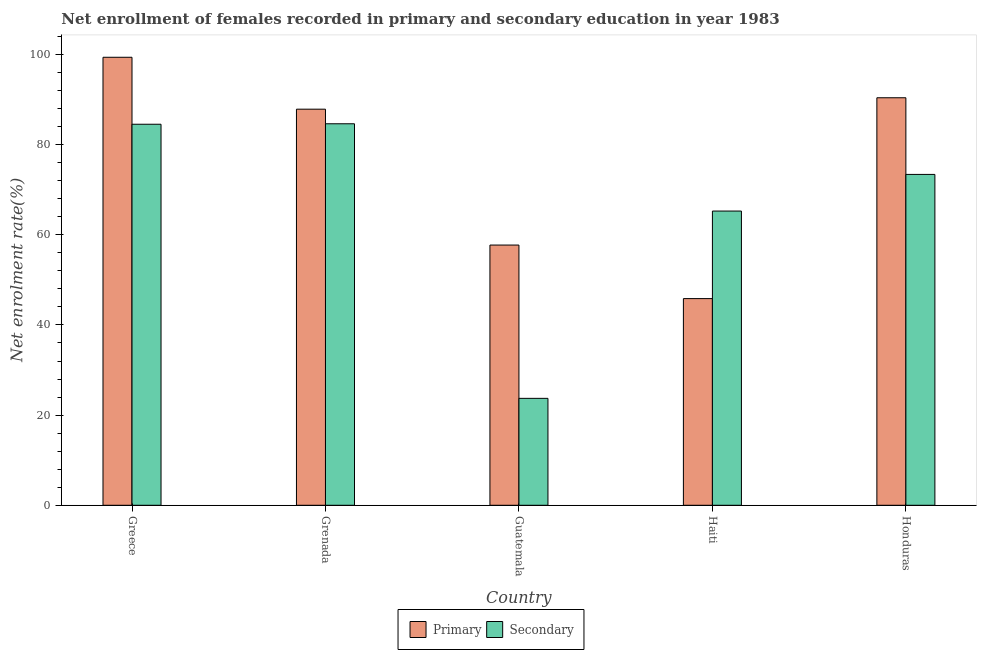How many different coloured bars are there?
Offer a very short reply. 2. Are the number of bars on each tick of the X-axis equal?
Keep it short and to the point. Yes. What is the label of the 3rd group of bars from the left?
Offer a very short reply. Guatemala. In how many cases, is the number of bars for a given country not equal to the number of legend labels?
Provide a short and direct response. 0. What is the enrollment rate in secondary education in Grenada?
Make the answer very short. 84.62. Across all countries, what is the maximum enrollment rate in primary education?
Keep it short and to the point. 99.37. Across all countries, what is the minimum enrollment rate in secondary education?
Keep it short and to the point. 23.71. In which country was the enrollment rate in secondary education maximum?
Your answer should be very brief. Grenada. In which country was the enrollment rate in secondary education minimum?
Your response must be concise. Guatemala. What is the total enrollment rate in primary education in the graph?
Provide a short and direct response. 381.18. What is the difference between the enrollment rate in secondary education in Greece and that in Guatemala?
Ensure brevity in your answer.  60.8. What is the difference between the enrollment rate in secondary education in Grenada and the enrollment rate in primary education in Honduras?
Your answer should be compact. -5.77. What is the average enrollment rate in primary education per country?
Ensure brevity in your answer.  76.24. What is the difference between the enrollment rate in secondary education and enrollment rate in primary education in Guatemala?
Offer a very short reply. -34. In how many countries, is the enrollment rate in secondary education greater than 72 %?
Provide a succinct answer. 3. What is the ratio of the enrollment rate in secondary education in Greece to that in Grenada?
Keep it short and to the point. 1. What is the difference between the highest and the second highest enrollment rate in primary education?
Give a very brief answer. 8.98. What is the difference between the highest and the lowest enrollment rate in secondary education?
Provide a succinct answer. 60.91. What does the 1st bar from the left in Haiti represents?
Offer a very short reply. Primary. What does the 1st bar from the right in Honduras represents?
Provide a succinct answer. Secondary. Are all the bars in the graph horizontal?
Your answer should be compact. No. How many countries are there in the graph?
Offer a very short reply. 5. What is the difference between two consecutive major ticks on the Y-axis?
Your answer should be compact. 20. Does the graph contain any zero values?
Offer a terse response. No. Does the graph contain grids?
Give a very brief answer. No. How many legend labels are there?
Provide a succinct answer. 2. How are the legend labels stacked?
Keep it short and to the point. Horizontal. What is the title of the graph?
Offer a very short reply. Net enrollment of females recorded in primary and secondary education in year 1983. Does "Females" appear as one of the legend labels in the graph?
Your response must be concise. No. What is the label or title of the Y-axis?
Provide a succinct answer. Net enrolment rate(%). What is the Net enrolment rate(%) of Primary in Greece?
Ensure brevity in your answer.  99.37. What is the Net enrolment rate(%) of Secondary in Greece?
Make the answer very short. 84.52. What is the Net enrolment rate(%) in Primary in Grenada?
Ensure brevity in your answer.  87.86. What is the Net enrolment rate(%) of Secondary in Grenada?
Keep it short and to the point. 84.62. What is the Net enrolment rate(%) in Primary in Guatemala?
Give a very brief answer. 57.72. What is the Net enrolment rate(%) in Secondary in Guatemala?
Offer a terse response. 23.71. What is the Net enrolment rate(%) of Primary in Haiti?
Make the answer very short. 45.84. What is the Net enrolment rate(%) in Secondary in Haiti?
Ensure brevity in your answer.  65.26. What is the Net enrolment rate(%) of Primary in Honduras?
Offer a terse response. 90.39. What is the Net enrolment rate(%) in Secondary in Honduras?
Your response must be concise. 73.39. Across all countries, what is the maximum Net enrolment rate(%) in Primary?
Your answer should be very brief. 99.37. Across all countries, what is the maximum Net enrolment rate(%) in Secondary?
Offer a very short reply. 84.62. Across all countries, what is the minimum Net enrolment rate(%) of Primary?
Provide a succinct answer. 45.84. Across all countries, what is the minimum Net enrolment rate(%) in Secondary?
Keep it short and to the point. 23.71. What is the total Net enrolment rate(%) in Primary in the graph?
Your response must be concise. 381.18. What is the total Net enrolment rate(%) in Secondary in the graph?
Your response must be concise. 331.5. What is the difference between the Net enrolment rate(%) in Primary in Greece and that in Grenada?
Provide a succinct answer. 11.51. What is the difference between the Net enrolment rate(%) of Secondary in Greece and that in Grenada?
Offer a terse response. -0.1. What is the difference between the Net enrolment rate(%) in Primary in Greece and that in Guatemala?
Make the answer very short. 41.65. What is the difference between the Net enrolment rate(%) of Secondary in Greece and that in Guatemala?
Make the answer very short. 60.8. What is the difference between the Net enrolment rate(%) in Primary in Greece and that in Haiti?
Your response must be concise. 53.53. What is the difference between the Net enrolment rate(%) of Secondary in Greece and that in Haiti?
Offer a very short reply. 19.25. What is the difference between the Net enrolment rate(%) of Primary in Greece and that in Honduras?
Make the answer very short. 8.98. What is the difference between the Net enrolment rate(%) of Secondary in Greece and that in Honduras?
Your answer should be compact. 11.13. What is the difference between the Net enrolment rate(%) of Primary in Grenada and that in Guatemala?
Provide a short and direct response. 30.14. What is the difference between the Net enrolment rate(%) in Secondary in Grenada and that in Guatemala?
Give a very brief answer. 60.91. What is the difference between the Net enrolment rate(%) of Primary in Grenada and that in Haiti?
Your answer should be compact. 42.02. What is the difference between the Net enrolment rate(%) of Secondary in Grenada and that in Haiti?
Make the answer very short. 19.36. What is the difference between the Net enrolment rate(%) in Primary in Grenada and that in Honduras?
Make the answer very short. -2.53. What is the difference between the Net enrolment rate(%) of Secondary in Grenada and that in Honduras?
Provide a short and direct response. 11.23. What is the difference between the Net enrolment rate(%) in Primary in Guatemala and that in Haiti?
Your answer should be compact. 11.88. What is the difference between the Net enrolment rate(%) of Secondary in Guatemala and that in Haiti?
Provide a short and direct response. -41.55. What is the difference between the Net enrolment rate(%) in Primary in Guatemala and that in Honduras?
Offer a terse response. -32.67. What is the difference between the Net enrolment rate(%) in Secondary in Guatemala and that in Honduras?
Ensure brevity in your answer.  -49.67. What is the difference between the Net enrolment rate(%) of Primary in Haiti and that in Honduras?
Keep it short and to the point. -44.55. What is the difference between the Net enrolment rate(%) in Secondary in Haiti and that in Honduras?
Give a very brief answer. -8.13. What is the difference between the Net enrolment rate(%) of Primary in Greece and the Net enrolment rate(%) of Secondary in Grenada?
Provide a short and direct response. 14.75. What is the difference between the Net enrolment rate(%) of Primary in Greece and the Net enrolment rate(%) of Secondary in Guatemala?
Offer a very short reply. 75.66. What is the difference between the Net enrolment rate(%) in Primary in Greece and the Net enrolment rate(%) in Secondary in Haiti?
Provide a succinct answer. 34.11. What is the difference between the Net enrolment rate(%) of Primary in Greece and the Net enrolment rate(%) of Secondary in Honduras?
Provide a succinct answer. 25.98. What is the difference between the Net enrolment rate(%) of Primary in Grenada and the Net enrolment rate(%) of Secondary in Guatemala?
Provide a short and direct response. 64.14. What is the difference between the Net enrolment rate(%) of Primary in Grenada and the Net enrolment rate(%) of Secondary in Haiti?
Give a very brief answer. 22.6. What is the difference between the Net enrolment rate(%) of Primary in Grenada and the Net enrolment rate(%) of Secondary in Honduras?
Your response must be concise. 14.47. What is the difference between the Net enrolment rate(%) in Primary in Guatemala and the Net enrolment rate(%) in Secondary in Haiti?
Provide a succinct answer. -7.54. What is the difference between the Net enrolment rate(%) of Primary in Guatemala and the Net enrolment rate(%) of Secondary in Honduras?
Keep it short and to the point. -15.67. What is the difference between the Net enrolment rate(%) of Primary in Haiti and the Net enrolment rate(%) of Secondary in Honduras?
Offer a terse response. -27.55. What is the average Net enrolment rate(%) in Primary per country?
Your answer should be very brief. 76.24. What is the average Net enrolment rate(%) of Secondary per country?
Keep it short and to the point. 66.3. What is the difference between the Net enrolment rate(%) in Primary and Net enrolment rate(%) in Secondary in Greece?
Provide a succinct answer. 14.85. What is the difference between the Net enrolment rate(%) of Primary and Net enrolment rate(%) of Secondary in Grenada?
Your answer should be compact. 3.24. What is the difference between the Net enrolment rate(%) in Primary and Net enrolment rate(%) in Secondary in Guatemala?
Your response must be concise. 34. What is the difference between the Net enrolment rate(%) of Primary and Net enrolment rate(%) of Secondary in Haiti?
Offer a terse response. -19.42. What is the difference between the Net enrolment rate(%) of Primary and Net enrolment rate(%) of Secondary in Honduras?
Provide a succinct answer. 17. What is the ratio of the Net enrolment rate(%) in Primary in Greece to that in Grenada?
Ensure brevity in your answer.  1.13. What is the ratio of the Net enrolment rate(%) in Secondary in Greece to that in Grenada?
Your answer should be very brief. 1. What is the ratio of the Net enrolment rate(%) in Primary in Greece to that in Guatemala?
Provide a short and direct response. 1.72. What is the ratio of the Net enrolment rate(%) of Secondary in Greece to that in Guatemala?
Your response must be concise. 3.56. What is the ratio of the Net enrolment rate(%) in Primary in Greece to that in Haiti?
Offer a terse response. 2.17. What is the ratio of the Net enrolment rate(%) in Secondary in Greece to that in Haiti?
Ensure brevity in your answer.  1.29. What is the ratio of the Net enrolment rate(%) in Primary in Greece to that in Honduras?
Provide a short and direct response. 1.1. What is the ratio of the Net enrolment rate(%) in Secondary in Greece to that in Honduras?
Give a very brief answer. 1.15. What is the ratio of the Net enrolment rate(%) in Primary in Grenada to that in Guatemala?
Your response must be concise. 1.52. What is the ratio of the Net enrolment rate(%) of Secondary in Grenada to that in Guatemala?
Provide a succinct answer. 3.57. What is the ratio of the Net enrolment rate(%) in Primary in Grenada to that in Haiti?
Your response must be concise. 1.92. What is the ratio of the Net enrolment rate(%) of Secondary in Grenada to that in Haiti?
Your answer should be compact. 1.3. What is the ratio of the Net enrolment rate(%) of Primary in Grenada to that in Honduras?
Ensure brevity in your answer.  0.97. What is the ratio of the Net enrolment rate(%) of Secondary in Grenada to that in Honduras?
Your answer should be compact. 1.15. What is the ratio of the Net enrolment rate(%) in Primary in Guatemala to that in Haiti?
Make the answer very short. 1.26. What is the ratio of the Net enrolment rate(%) in Secondary in Guatemala to that in Haiti?
Make the answer very short. 0.36. What is the ratio of the Net enrolment rate(%) of Primary in Guatemala to that in Honduras?
Your answer should be very brief. 0.64. What is the ratio of the Net enrolment rate(%) in Secondary in Guatemala to that in Honduras?
Your answer should be very brief. 0.32. What is the ratio of the Net enrolment rate(%) of Primary in Haiti to that in Honduras?
Provide a succinct answer. 0.51. What is the ratio of the Net enrolment rate(%) of Secondary in Haiti to that in Honduras?
Provide a succinct answer. 0.89. What is the difference between the highest and the second highest Net enrolment rate(%) of Primary?
Offer a terse response. 8.98. What is the difference between the highest and the second highest Net enrolment rate(%) in Secondary?
Offer a very short reply. 0.1. What is the difference between the highest and the lowest Net enrolment rate(%) of Primary?
Ensure brevity in your answer.  53.53. What is the difference between the highest and the lowest Net enrolment rate(%) in Secondary?
Provide a short and direct response. 60.91. 